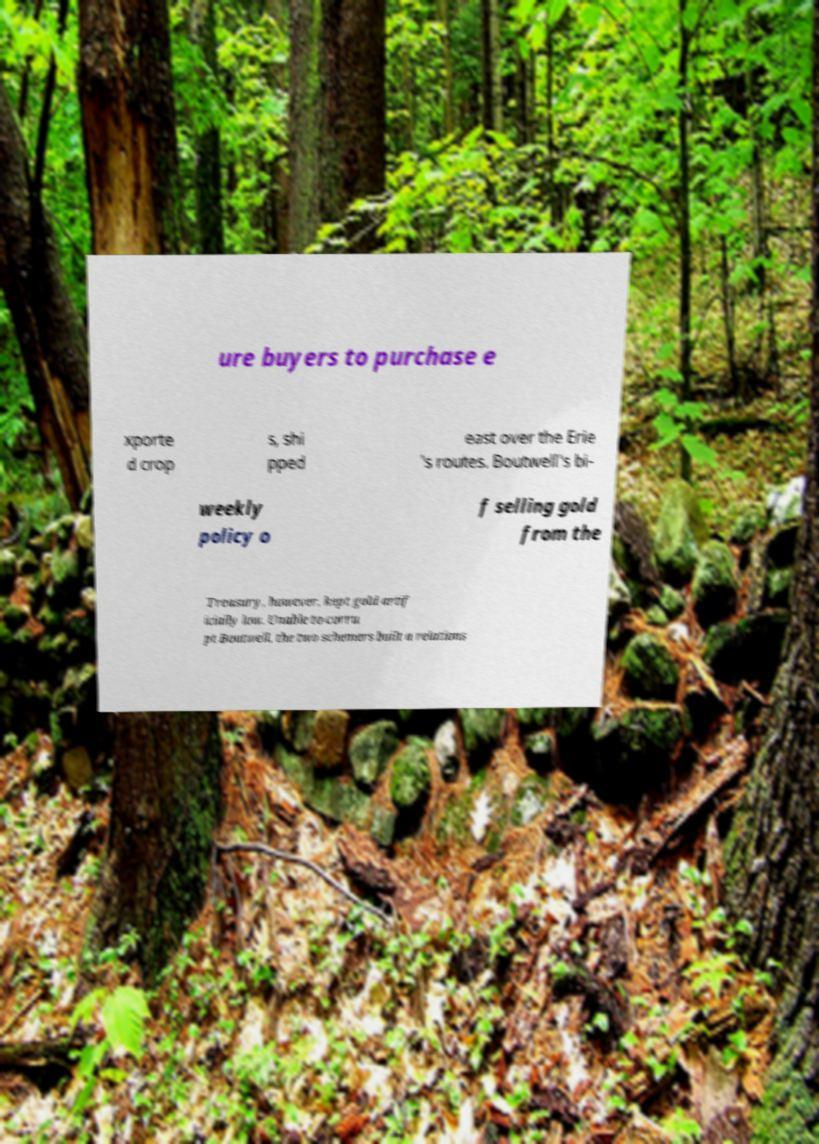Please identify and transcribe the text found in this image. ure buyers to purchase e xporte d crop s, shi pped east over the Erie 's routes. Boutwell's bi- weekly policy o f selling gold from the Treasury, however, kept gold artif icially low. Unable to corru pt Boutwell, the two schemers built a relations 